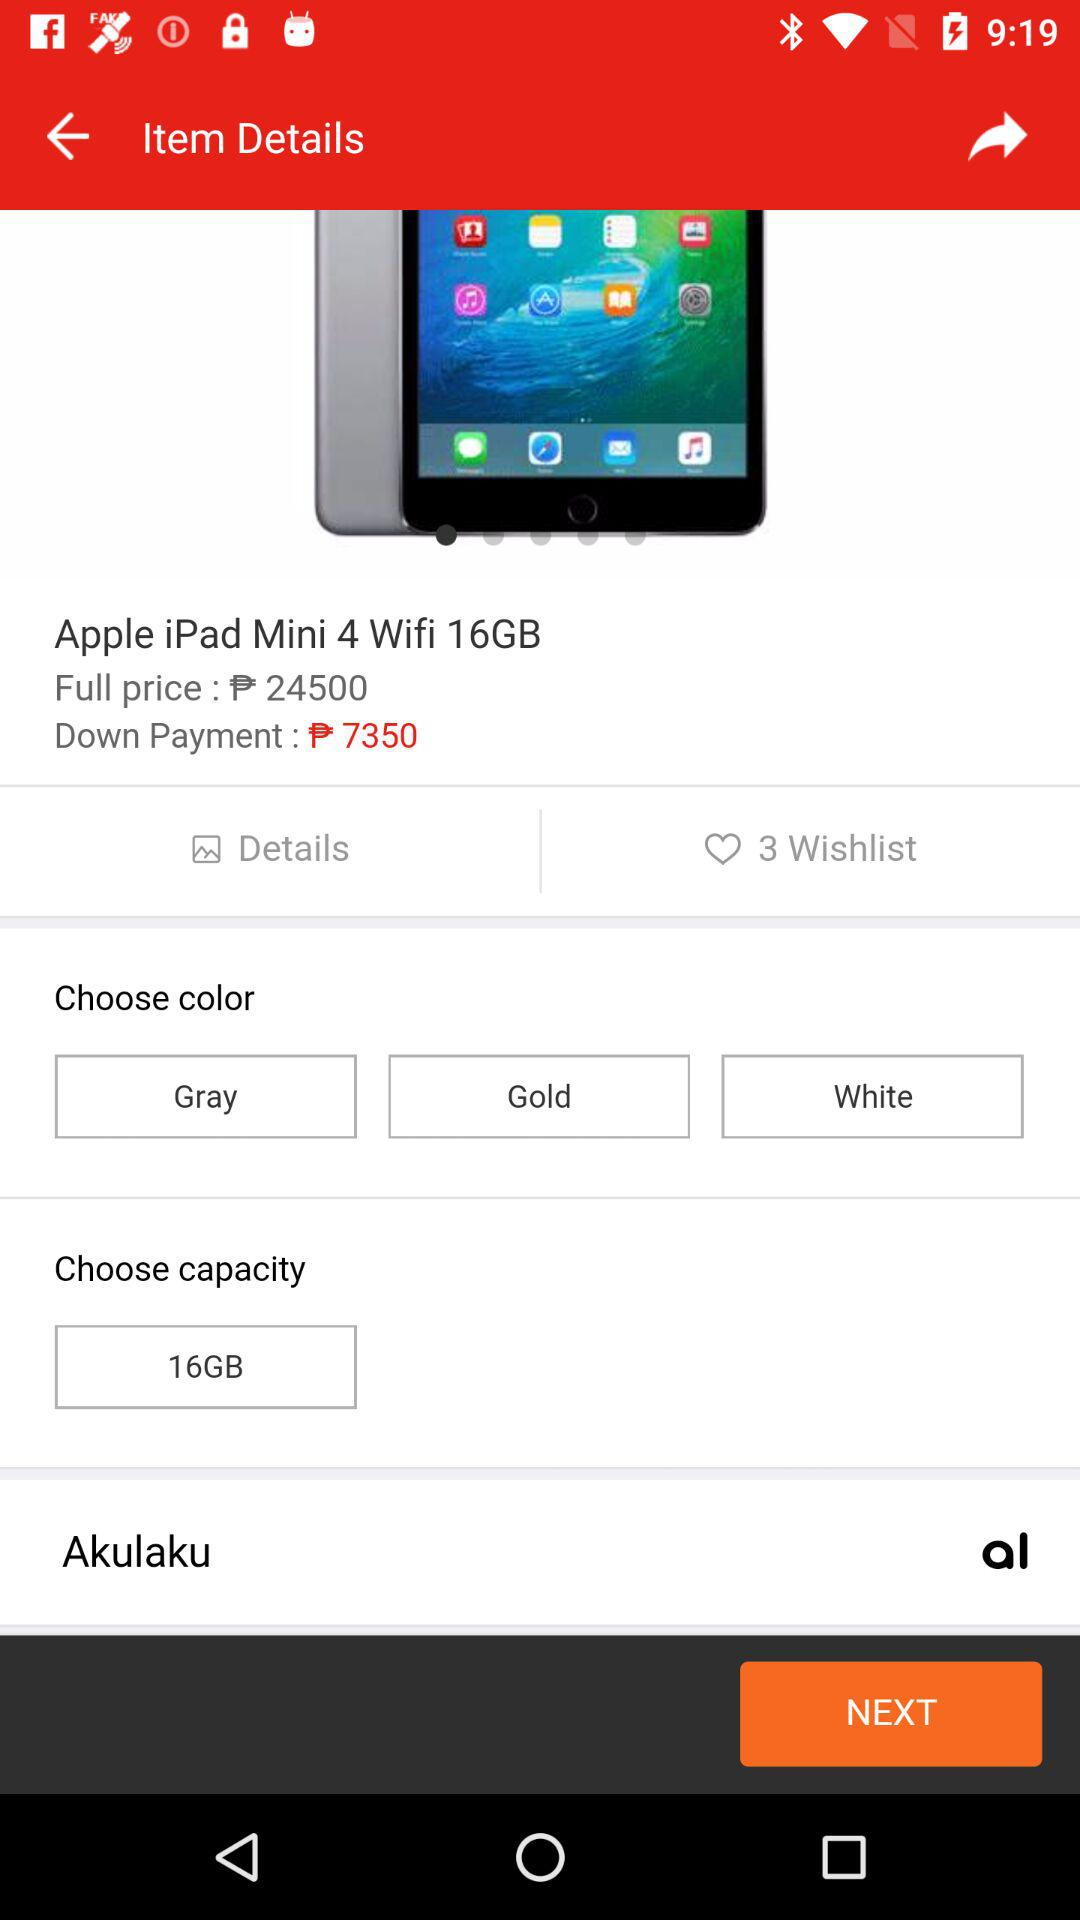What is the full price? The full price is ₱24500. 